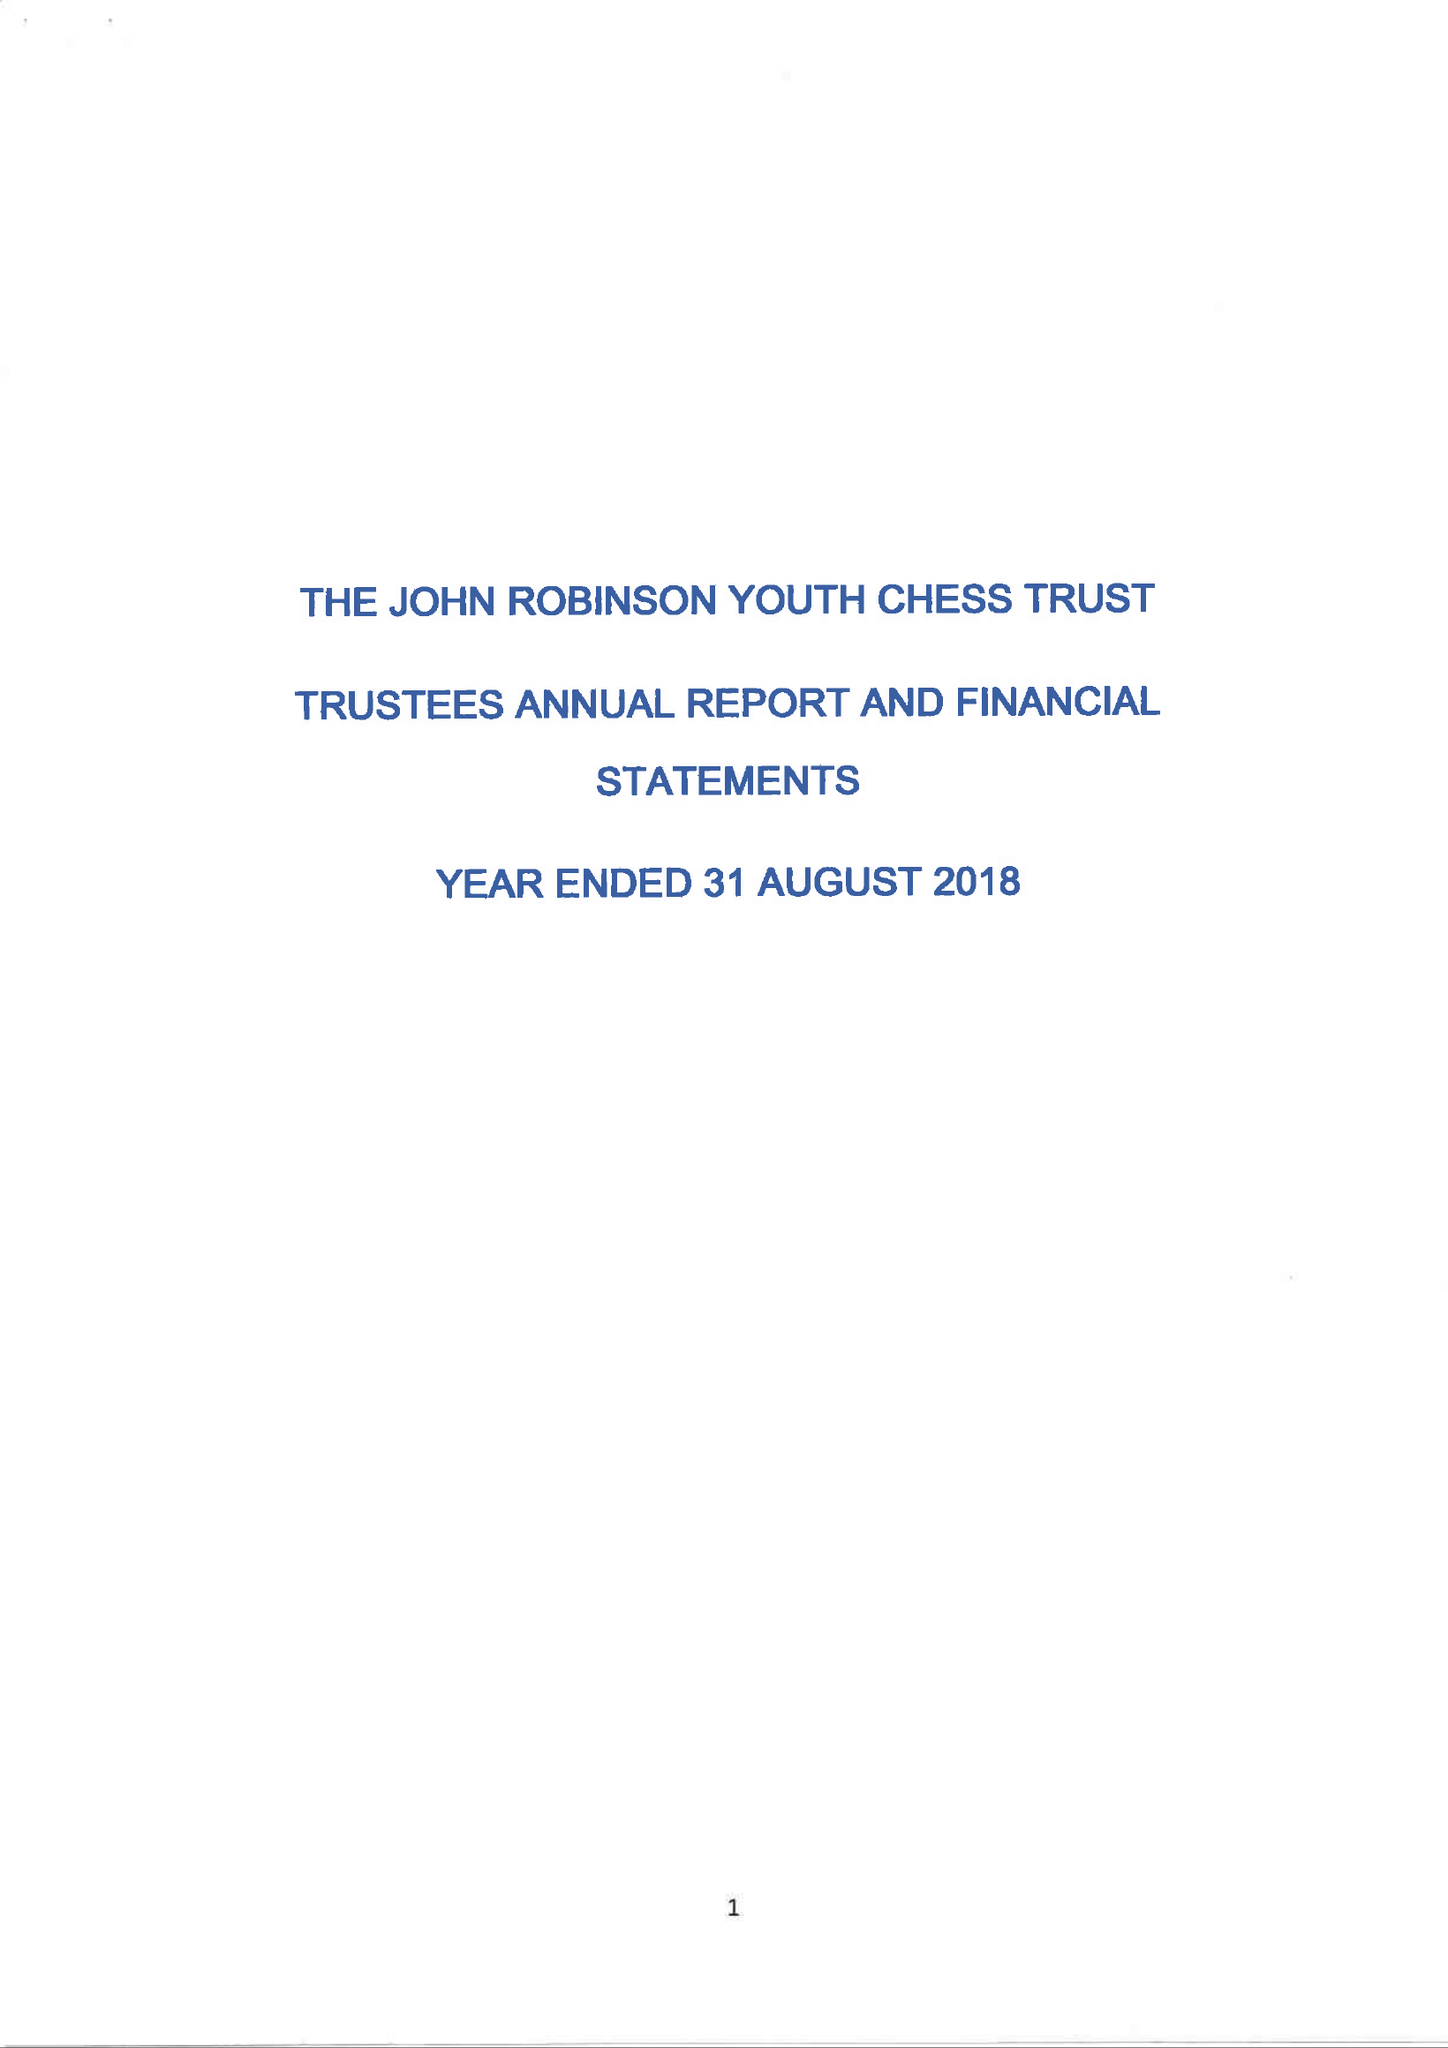What is the value for the address__postcode?
Answer the question using a single word or phrase. RH10 7FT 